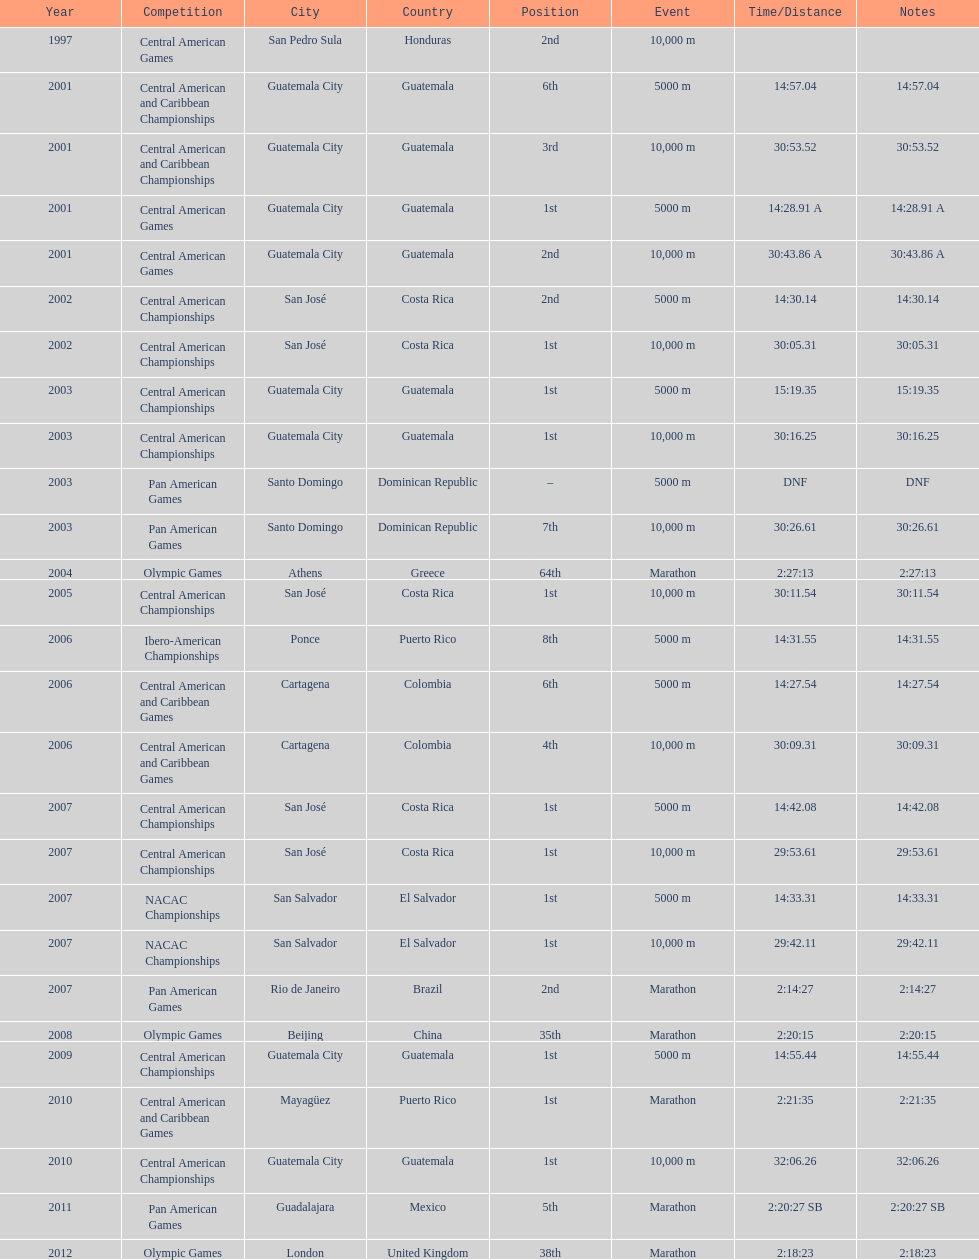Could you parse the entire table as a dict? {'header': ['Year', 'Competition', 'City', 'Country', 'Position', 'Event', 'Time/Distance', 'Notes'], 'rows': [['1997', 'Central American Games', 'San Pedro Sula', 'Honduras', '2nd', '10,000 m', '', ''], ['2001', 'Central American and Caribbean Championships', 'Guatemala City', 'Guatemala', '6th', '5000 m', '14:57.04', '14:57.04'], ['2001', 'Central American and Caribbean Championships', 'Guatemala City', 'Guatemala', '3rd', '10,000 m', '30:53.52', '30:53.52'], ['2001', 'Central American Games', 'Guatemala City', 'Guatemala', '1st', '5000 m', '14:28.91 A', '14:28.91 A'], ['2001', 'Central American Games', 'Guatemala City', 'Guatemala', '2nd', '10,000 m', '30:43.86 A', '30:43.86 A'], ['2002', 'Central American Championships', 'San José', 'Costa Rica', '2nd', '5000 m', '14:30.14', '14:30.14'], ['2002', 'Central American Championships', 'San José', 'Costa Rica', '1st', '10,000 m', '30:05.31', '30:05.31'], ['2003', 'Central American Championships', 'Guatemala City', 'Guatemala', '1st', '5000 m', '15:19.35', '15:19.35'], ['2003', 'Central American Championships', 'Guatemala City', 'Guatemala', '1st', '10,000 m', '30:16.25', '30:16.25'], ['2003', 'Pan American Games', 'Santo Domingo', 'Dominican Republic', '–', '5000 m', 'DNF', 'DNF'], ['2003', 'Pan American Games', 'Santo Domingo', 'Dominican Republic', '7th', '10,000 m', '30:26.61', '30:26.61'], ['2004', 'Olympic Games', 'Athens', 'Greece', '64th', 'Marathon', '2:27:13', '2:27:13'], ['2005', 'Central American Championships', 'San José', 'Costa Rica', '1st', '10,000 m', '30:11.54', '30:11.54'], ['2006', 'Ibero-American Championships', 'Ponce', 'Puerto Rico', '8th', '5000 m', '14:31.55', '14:31.55'], ['2006', 'Central American and Caribbean Games', 'Cartagena', 'Colombia', '6th', '5000 m', '14:27.54', '14:27.54'], ['2006', 'Central American and Caribbean Games', 'Cartagena', 'Colombia', '4th', '10,000 m', '30:09.31', '30:09.31'], ['2007', 'Central American Championships', 'San José', 'Costa Rica', '1st', '5000 m', '14:42.08', '14:42.08'], ['2007', 'Central American Championships', 'San José', 'Costa Rica', '1st', '10,000 m', '29:53.61', '29:53.61'], ['2007', 'NACAC Championships', 'San Salvador', 'El Salvador', '1st', '5000 m', '14:33.31', '14:33.31'], ['2007', 'NACAC Championships', 'San Salvador', 'El Salvador', '1st', '10,000 m', '29:42.11', '29:42.11'], ['2007', 'Pan American Games', 'Rio de Janeiro', 'Brazil', '2nd', 'Marathon', '2:14:27', '2:14:27'], ['2008', 'Olympic Games', 'Beijing', 'China', '35th', 'Marathon', '2:20:15', '2:20:15'], ['2009', 'Central American Championships', 'Guatemala City', 'Guatemala', '1st', '5000 m', '14:55.44', '14:55.44'], ['2010', 'Central American and Caribbean Games', 'Mayagüez', 'Puerto Rico', '1st', 'Marathon', '2:21:35', '2:21:35'], ['2010', 'Central American Championships', 'Guatemala City', 'Guatemala', '1st', '10,000 m', '32:06.26', '32:06.26'], ['2011', 'Pan American Games', 'Guadalajara', 'Mexico', '5th', 'Marathon', '2:20:27 SB', '2:20:27 SB'], ['2012', 'Olympic Games', 'London', 'United Kingdom', '38th', 'Marathon', '2:18:23', '2:18:23']]} Where was the only 64th position held? Athens, Greece. 